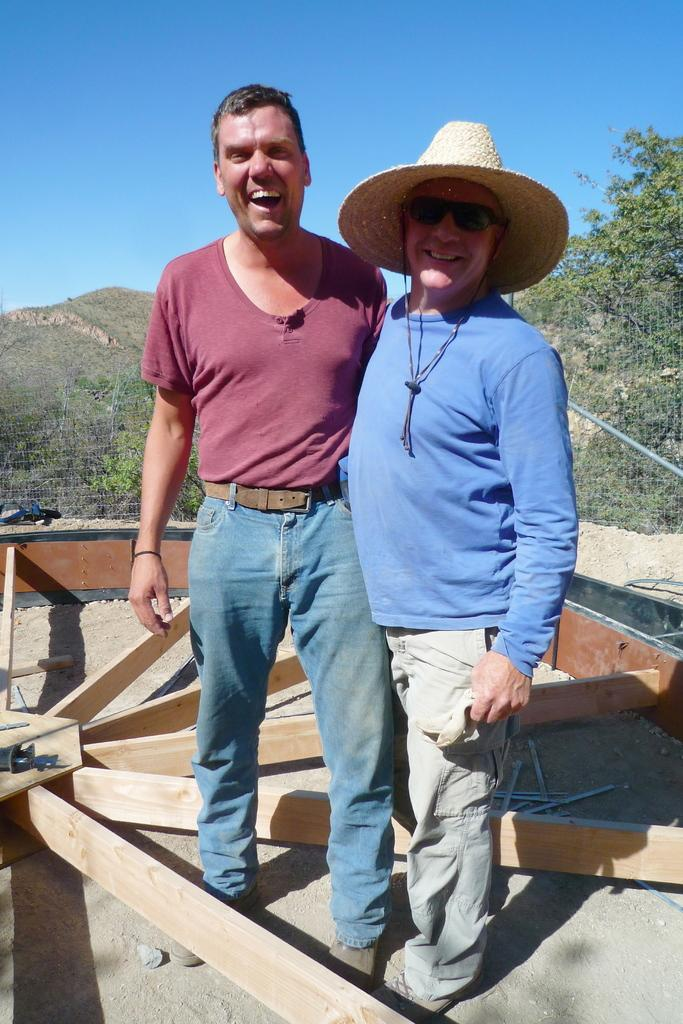How many men are present in the image? There are two men standing in the image. What can be seen in the foreground of the image? There are wooden planks and other objects in the foreground of the image. What is visible in the background of the image? There are trees, a mountain, and the sky visible in the background of the image. Who is the humor expert in the image? There is no humor expert present in the image; it features two men standing near wooden planks and other objects, with a mountain and trees in the background. What type of fruit can be seen hanging from the trees in the image? There is no fruit visible in the image; only trees, a mountain, and the sky are present in the background. 